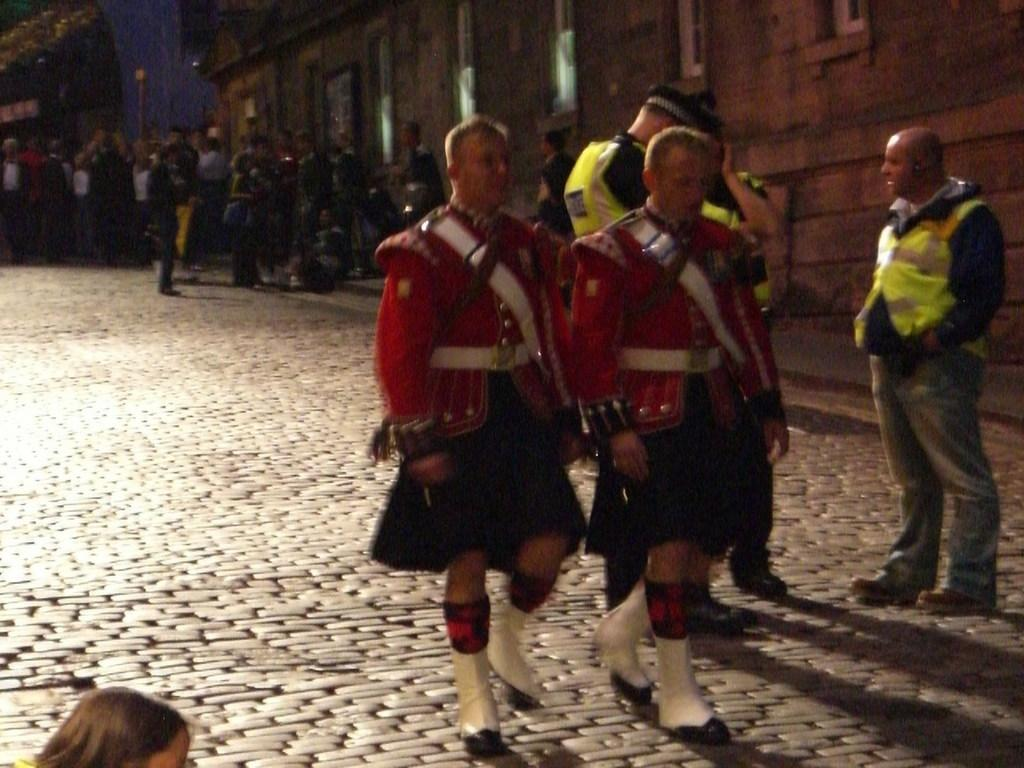How many people are in the image? There is a group of people in the image. What can be observed about the clothing of the people in the image? The people are wearing different color dresses. Where are the people located in the image? The people are on a road. What type of structure is visible in the image? There is a building with windows in the image. Can you see any tables or trains in the image? There are no tables or trains visible in the image. Is there a duck in the image? There is no duck present in the image. 